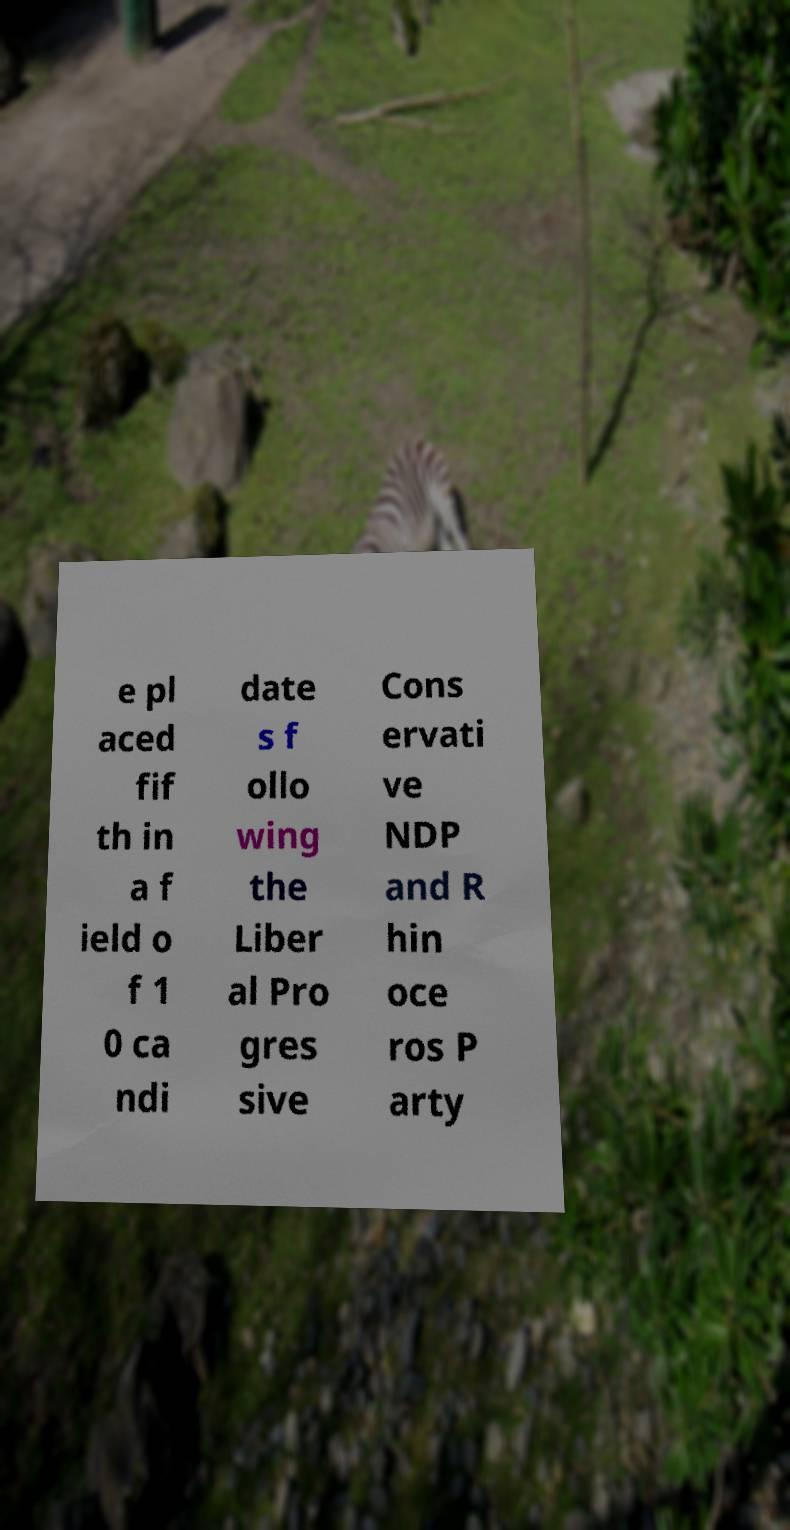Can you accurately transcribe the text from the provided image for me? e pl aced fif th in a f ield o f 1 0 ca ndi date s f ollo wing the Liber al Pro gres sive Cons ervati ve NDP and R hin oce ros P arty 